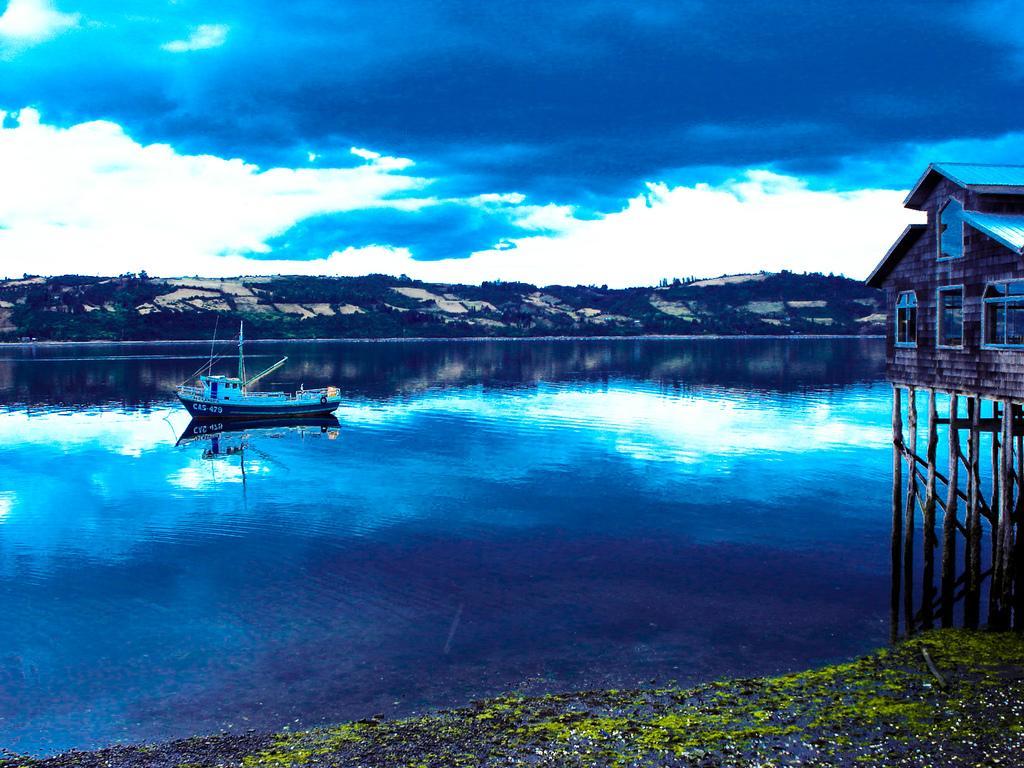Could you give a brief overview of what you see in this image? In this image I can see a boat which is white in color on the water. I can see the ground, few wooden pillars and a house on the pillars. I can see few windows of the house. In the background I can see the ground, few trees and the sky. 